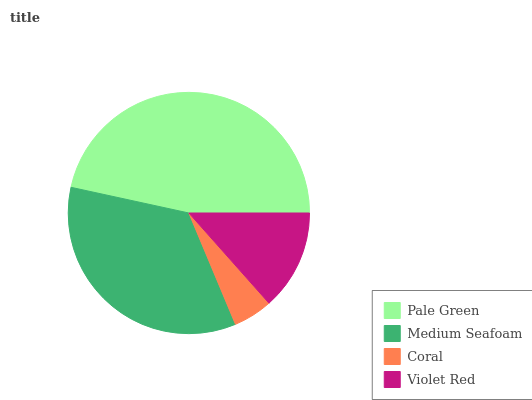Is Coral the minimum?
Answer yes or no. Yes. Is Pale Green the maximum?
Answer yes or no. Yes. Is Medium Seafoam the minimum?
Answer yes or no. No. Is Medium Seafoam the maximum?
Answer yes or no. No. Is Pale Green greater than Medium Seafoam?
Answer yes or no. Yes. Is Medium Seafoam less than Pale Green?
Answer yes or no. Yes. Is Medium Seafoam greater than Pale Green?
Answer yes or no. No. Is Pale Green less than Medium Seafoam?
Answer yes or no. No. Is Medium Seafoam the high median?
Answer yes or no. Yes. Is Violet Red the low median?
Answer yes or no. Yes. Is Pale Green the high median?
Answer yes or no. No. Is Coral the low median?
Answer yes or no. No. 